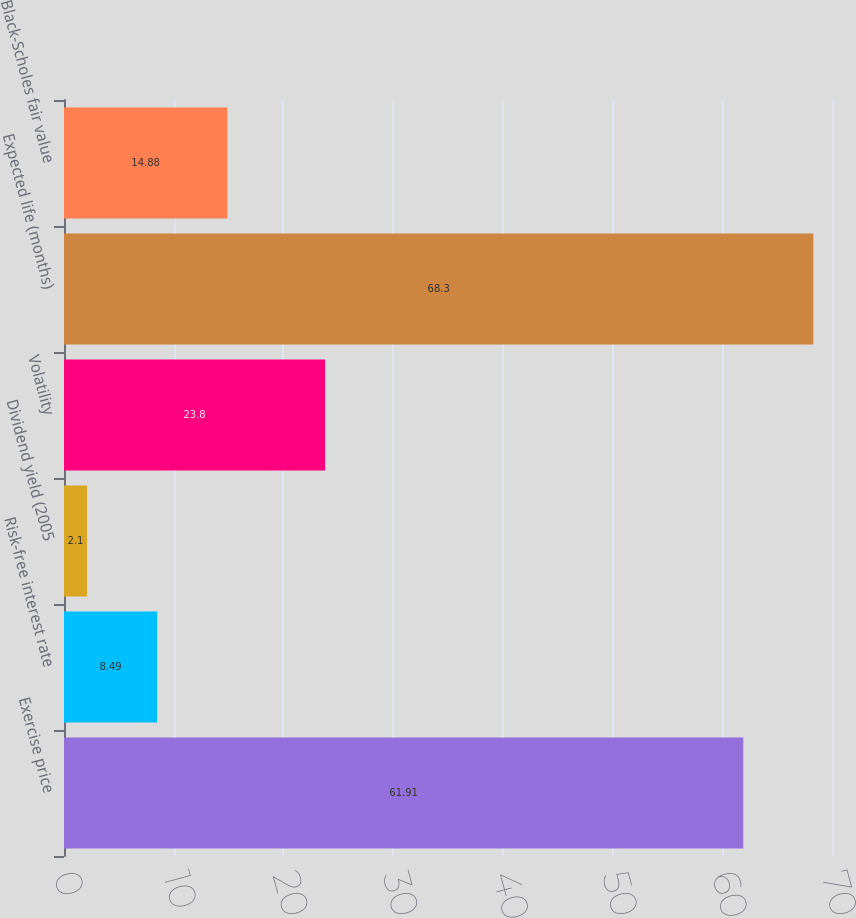Convert chart to OTSL. <chart><loc_0><loc_0><loc_500><loc_500><bar_chart><fcel>Exercise price<fcel>Risk-free interest rate<fcel>Dividend yield (2005<fcel>Volatility<fcel>Expected life (months)<fcel>Black-Scholes fair value<nl><fcel>61.91<fcel>8.49<fcel>2.1<fcel>23.8<fcel>68.3<fcel>14.88<nl></chart> 